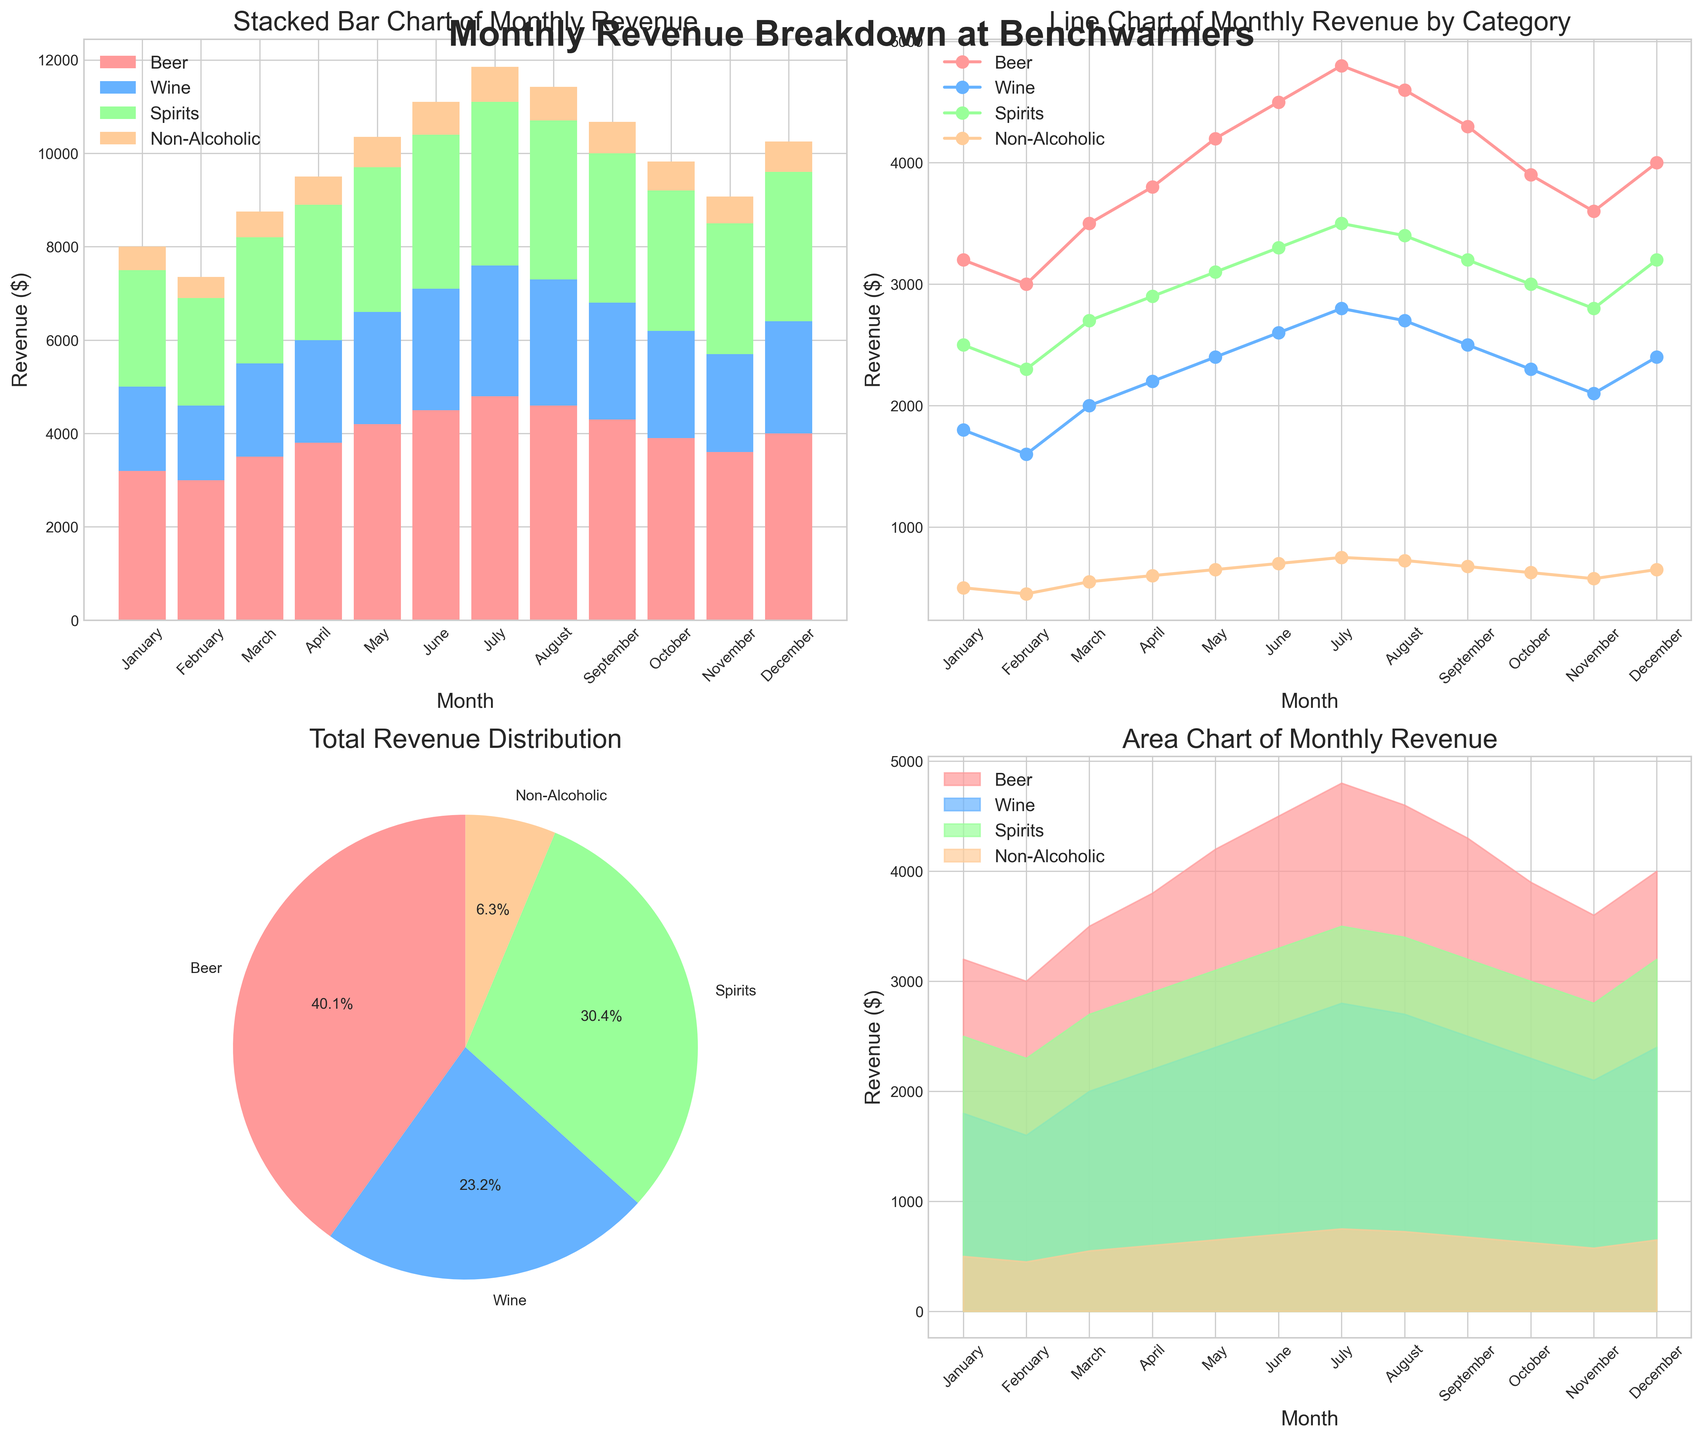What's the title of the figure? The title is displayed at the top center of the figure. It says "Monthly Revenue Breakdown at Benchwarmers" in large font.
Answer: Monthly Revenue Breakdown at Benchwarmers How many months are shown on the x-axis in the bar plot? The x-axis of the bar plot shows tick labels for each month from January to December. Counting these, there are 12 months.
Answer: 12 Which drink category generated the highest revenue in July according to the bar plot? In the bar plot, the height of each stacked bar component represents revenue. The category with the highest segment on top in July is "Beer."
Answer: Beer What percentage of total revenue comes from "Wine" in the pie chart? The pie chart shows labels and percentages for each segment. The label "Wine" has a percentage of 27.1%.
Answer: 27.1% Compare the revenue trends of "Beer" and "Non-Alcoholic" drinks over the year using the line chart. Which category shows a more consistent increase? The line chart plots revenue by month for each category. The "Beer" line has a consistent upward trend, while the "Non-Alcoholic" line has smaller and less consistent increases. So, "Beer" shows a more consistent increase.
Answer: Beer In the area chart, in which month does "Spirits" surpass the $3000 revenue mark? In the area chart, you can visually track the area shaded for "Spirits." The month when "Spirits" first exceeds $3000 is May.
Answer: May What is the combined revenue of "Beer" and "Wine" in December as shown in the bar plot? In the bar plot, the height of the "Beer" segment in December is $4000. Adding the "Wine" segment's height on top, $2400, the combined revenue is $4000 + $2400 = $6400.
Answer: $6400 How does the monthly revenue for "Spirits" and "Non-Alcoholic" compare in March according to the bar plot? According to the bar plot, in March, the revenue for "Spirits" is $2700, while for "Non-Alcoholic," it is $550. "Spirits" revenue is significantly higher.
Answer: Spirits is higher Which month shows the lowest overall revenue in the area chart? The area chart visually summarizes monthly revenue across all categories. January has the smallest combined area, making it the lowest revenue month.
Answer: January 